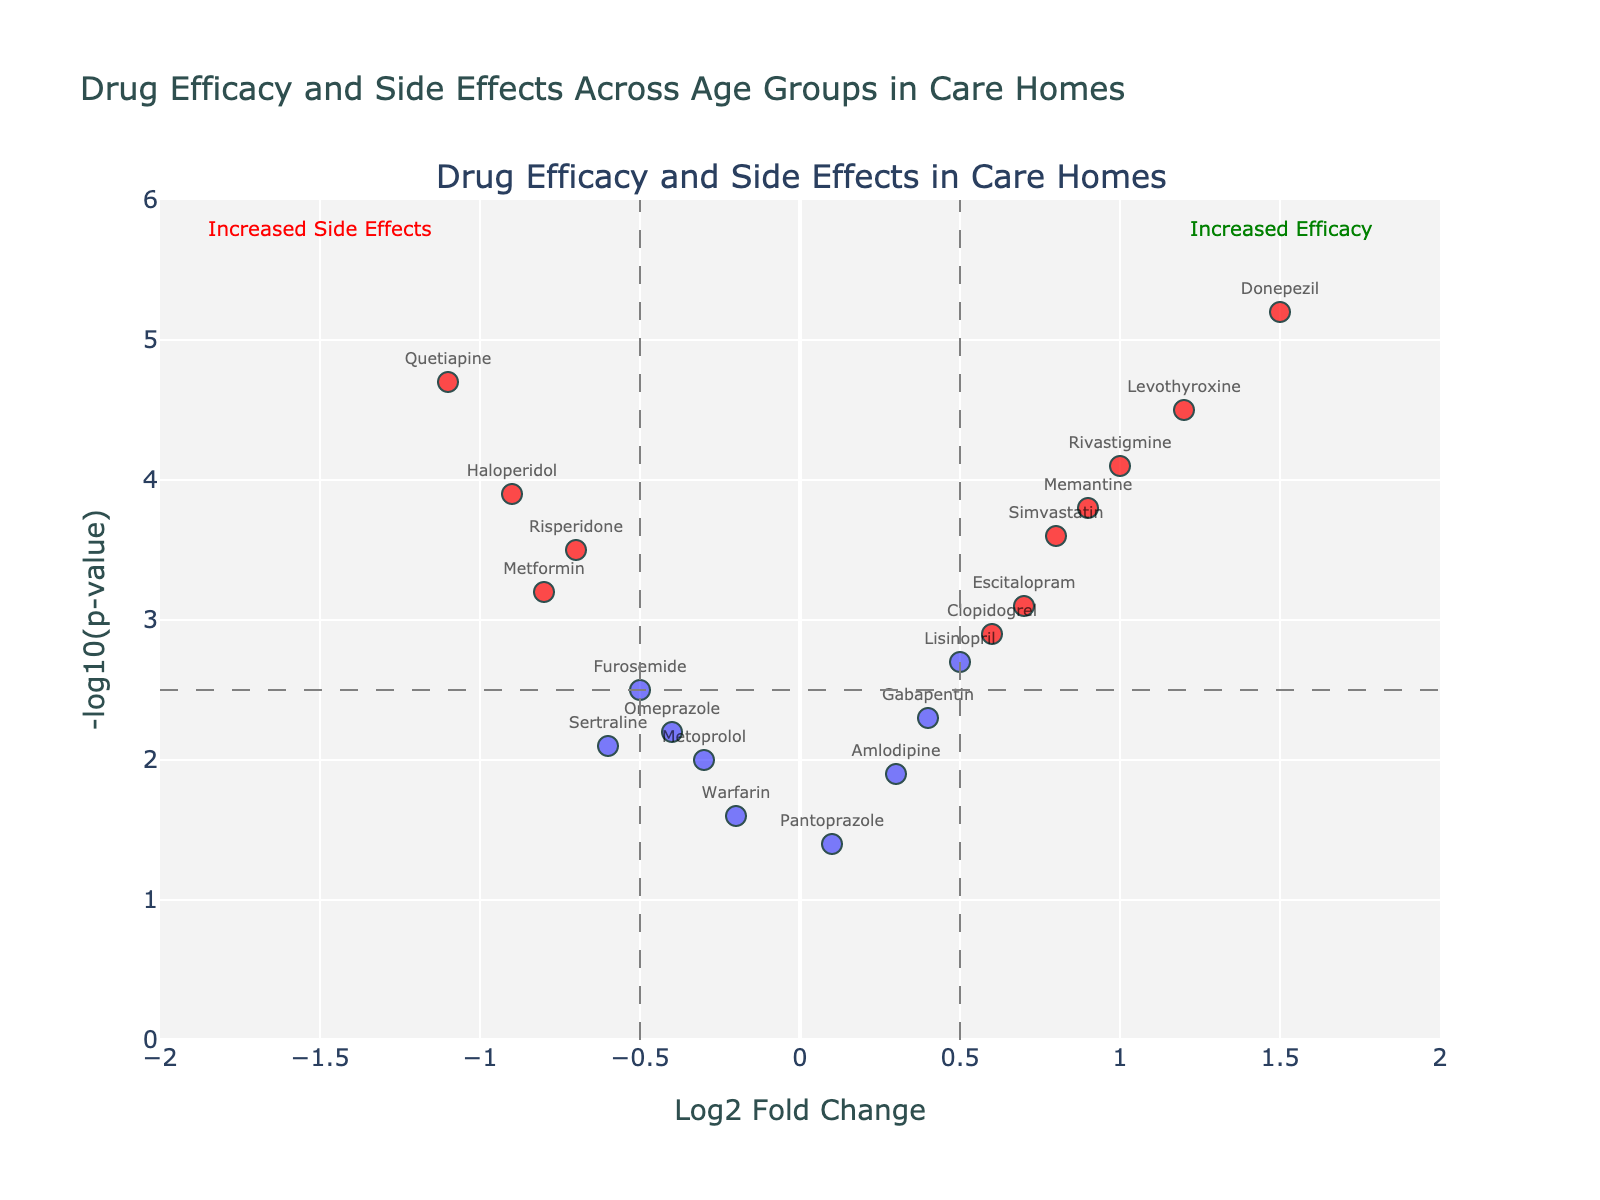Which drug shows the highest log2 fold change? To determine the drug with the highest log2 fold change, we look for the drug with the highest x-axis value.
Answer: Donepezil What is the title of the plot? The title is usually displayed at the top of the plot.
Answer: Drug Efficacy and Side Effects Across Age Groups in Care Homes How many drugs have both increased efficacy and a significant p-value (above thresholds)? Drugs with increased efficacy have positive log2 fold changes and high significant p-values. Look at the top right quadrant where x > 0.5 and y > 2.5.
Answer: 6 Which drugs have been identified as having significant side effects (log2 fold change less than -0.5)? Drugs on the left side below -0.5 on the x-axis represent increased side effects.
Answer: Quetiapine, Haloperidol, Metformin, Risperidone What color indicates drugs with significant fold changes and p-values on the plot? Observing the scatter plot, significant drugs are marked with a specific color. This color helps differentiate them.
Answer: Red What range is used for the log2 fold change axis? The range of the log2 fold change can be determined by looking at the x-axis limits.
Answer: -2 to 2 How many drugs are listed in the plot? Counting the markers on the plot will give the total number of drugs.
Answer: 18 Which drug has the lowest negative log10 p-value? The drug with the lowest y-axis value represents the lowest negative log10 p-value.
Answer: Pantoprazole Between Memantine and Risperidone, which has a higher log2 fold change? Comparing the log2 fold change values of Memantine and Risperidone involves comparing their x-axis values.
Answer: Memantine 